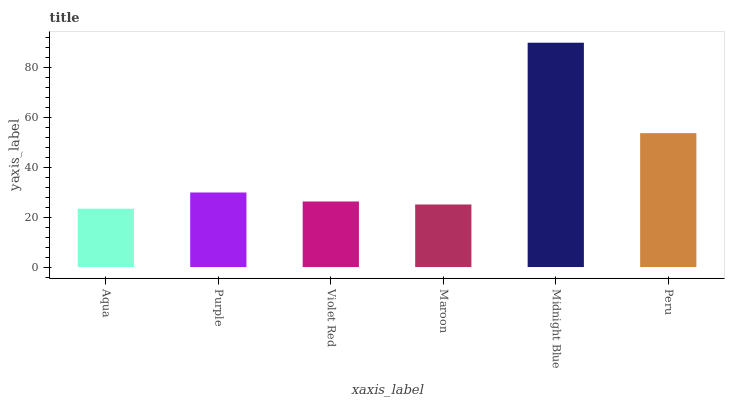Is Aqua the minimum?
Answer yes or no. Yes. Is Midnight Blue the maximum?
Answer yes or no. Yes. Is Purple the minimum?
Answer yes or no. No. Is Purple the maximum?
Answer yes or no. No. Is Purple greater than Aqua?
Answer yes or no. Yes. Is Aqua less than Purple?
Answer yes or no. Yes. Is Aqua greater than Purple?
Answer yes or no. No. Is Purple less than Aqua?
Answer yes or no. No. Is Purple the high median?
Answer yes or no. Yes. Is Violet Red the low median?
Answer yes or no. Yes. Is Aqua the high median?
Answer yes or no. No. Is Purple the low median?
Answer yes or no. No. 